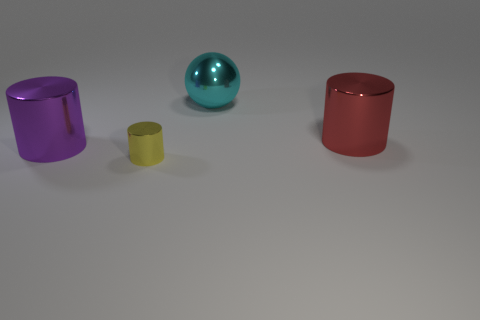There is a big object left of the tiny object; is its color the same as the shiny ball?
Give a very brief answer. No. What number of cylinders are large shiny objects or tiny yellow metallic things?
Make the answer very short. 3. There is a thing in front of the big metallic cylinder that is left of the large cyan shiny ball; what is its shape?
Provide a succinct answer. Cylinder. There is a thing behind the large metallic cylinder that is behind the large metal cylinder on the left side of the large cyan metal sphere; what is its size?
Your answer should be compact. Large. Does the purple thing have the same size as the red cylinder?
Offer a very short reply. Yes. How many things are either big purple metal spheres or cyan metallic objects?
Ensure brevity in your answer.  1. There is a purple metallic thing that is on the left side of the large shiny cylinder behind the purple cylinder; how big is it?
Make the answer very short. Large. What size is the cyan object?
Offer a very short reply. Large. What is the shape of the object that is in front of the shiny sphere and behind the purple metallic thing?
Ensure brevity in your answer.  Cylinder. What is the color of the other large object that is the same shape as the big red shiny object?
Give a very brief answer. Purple. 